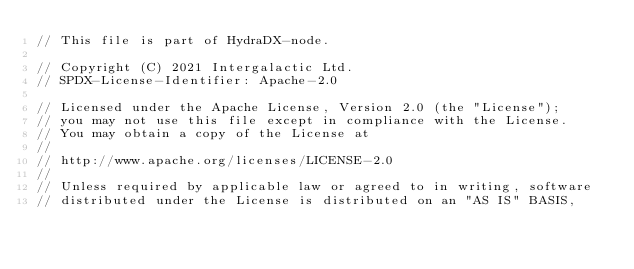<code> <loc_0><loc_0><loc_500><loc_500><_Rust_>// This file is part of HydraDX-node.

// Copyright (C) 2021 Intergalactic Ltd.
// SPDX-License-Identifier: Apache-2.0

// Licensed under the Apache License, Version 2.0 (the "License");
// you may not use this file except in compliance with the License.
// You may obtain a copy of the License at
//
// http://www.apache.org/licenses/LICENSE-2.0
//
// Unless required by applicable law or agreed to in writing, software
// distributed under the License is distributed on an "AS IS" BASIS,</code> 